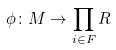<formula> <loc_0><loc_0><loc_500><loc_500>\phi \colon M \rightarrow \prod _ { i \in F } R</formula> 